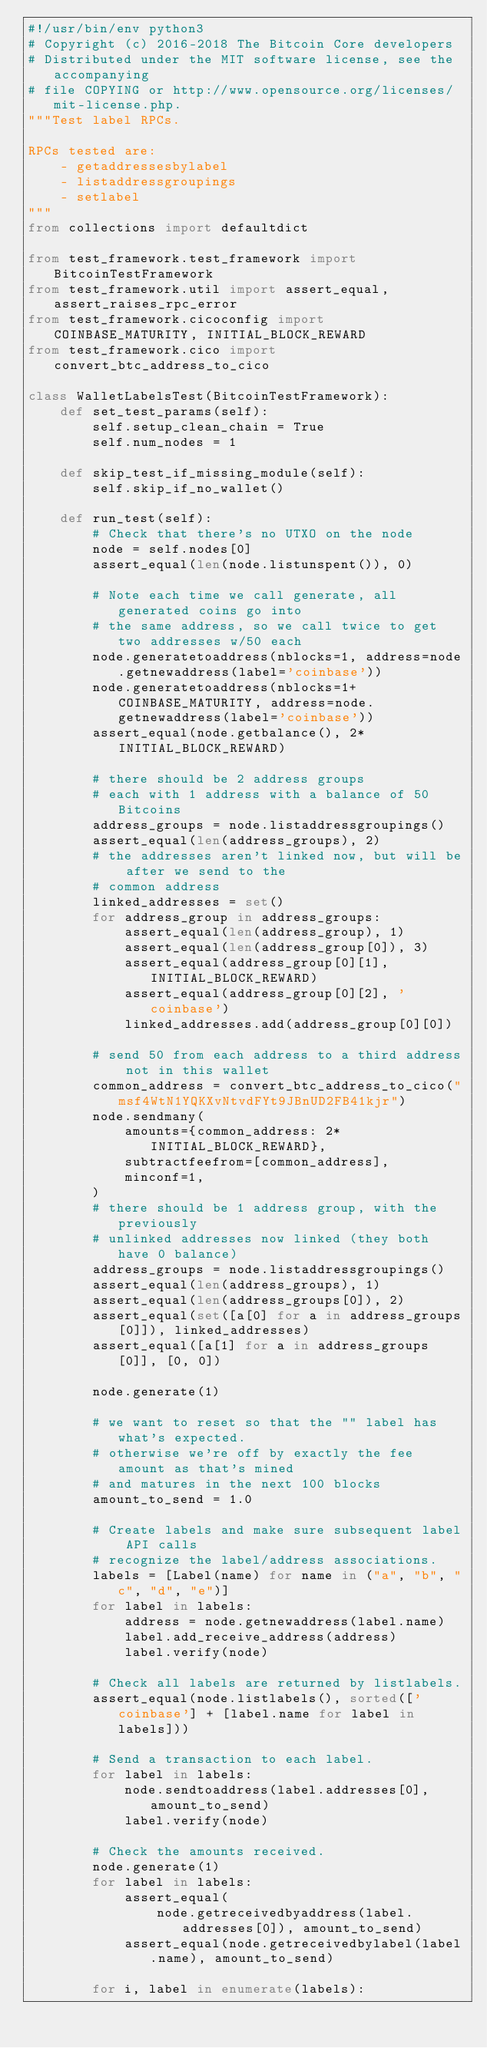Convert code to text. <code><loc_0><loc_0><loc_500><loc_500><_Python_>#!/usr/bin/env python3
# Copyright (c) 2016-2018 The Bitcoin Core developers
# Distributed under the MIT software license, see the accompanying
# file COPYING or http://www.opensource.org/licenses/mit-license.php.
"""Test label RPCs.

RPCs tested are:
    - getaddressesbylabel
    - listaddressgroupings
    - setlabel
"""
from collections import defaultdict

from test_framework.test_framework import BitcoinTestFramework
from test_framework.util import assert_equal, assert_raises_rpc_error
from test_framework.cicoconfig import COINBASE_MATURITY, INITIAL_BLOCK_REWARD
from test_framework.cico import convert_btc_address_to_cico

class WalletLabelsTest(BitcoinTestFramework):
    def set_test_params(self):
        self.setup_clean_chain = True
        self.num_nodes = 1

    def skip_test_if_missing_module(self):
        self.skip_if_no_wallet()

    def run_test(self):
        # Check that there's no UTXO on the node
        node = self.nodes[0]
        assert_equal(len(node.listunspent()), 0)

        # Note each time we call generate, all generated coins go into
        # the same address, so we call twice to get two addresses w/50 each
        node.generatetoaddress(nblocks=1, address=node.getnewaddress(label='coinbase'))
        node.generatetoaddress(nblocks=1+COINBASE_MATURITY, address=node.getnewaddress(label='coinbase'))
        assert_equal(node.getbalance(), 2*INITIAL_BLOCK_REWARD)

        # there should be 2 address groups
        # each with 1 address with a balance of 50 Bitcoins
        address_groups = node.listaddressgroupings()
        assert_equal(len(address_groups), 2)
        # the addresses aren't linked now, but will be after we send to the
        # common address
        linked_addresses = set()
        for address_group in address_groups:
            assert_equal(len(address_group), 1)
            assert_equal(len(address_group[0]), 3)
            assert_equal(address_group[0][1], INITIAL_BLOCK_REWARD)
            assert_equal(address_group[0][2], 'coinbase')
            linked_addresses.add(address_group[0][0])

        # send 50 from each address to a third address not in this wallet
        common_address = convert_btc_address_to_cico("msf4WtN1YQKXvNtvdFYt9JBnUD2FB41kjr")
        node.sendmany(
            amounts={common_address: 2*INITIAL_BLOCK_REWARD},
            subtractfeefrom=[common_address],
            minconf=1,
        )
        # there should be 1 address group, with the previously
        # unlinked addresses now linked (they both have 0 balance)
        address_groups = node.listaddressgroupings()
        assert_equal(len(address_groups), 1)
        assert_equal(len(address_groups[0]), 2)
        assert_equal(set([a[0] for a in address_groups[0]]), linked_addresses)
        assert_equal([a[1] for a in address_groups[0]], [0, 0])

        node.generate(1)

        # we want to reset so that the "" label has what's expected.
        # otherwise we're off by exactly the fee amount as that's mined
        # and matures in the next 100 blocks
        amount_to_send = 1.0

        # Create labels and make sure subsequent label API calls
        # recognize the label/address associations.
        labels = [Label(name) for name in ("a", "b", "c", "d", "e")]
        for label in labels:
            address = node.getnewaddress(label.name)
            label.add_receive_address(address)
            label.verify(node)

        # Check all labels are returned by listlabels.
        assert_equal(node.listlabels(), sorted(['coinbase'] + [label.name for label in labels]))

        # Send a transaction to each label.
        for label in labels:
            node.sendtoaddress(label.addresses[0], amount_to_send)
            label.verify(node)

        # Check the amounts received.
        node.generate(1)
        for label in labels:
            assert_equal(
                node.getreceivedbyaddress(label.addresses[0]), amount_to_send)
            assert_equal(node.getreceivedbylabel(label.name), amount_to_send)

        for i, label in enumerate(labels):</code> 